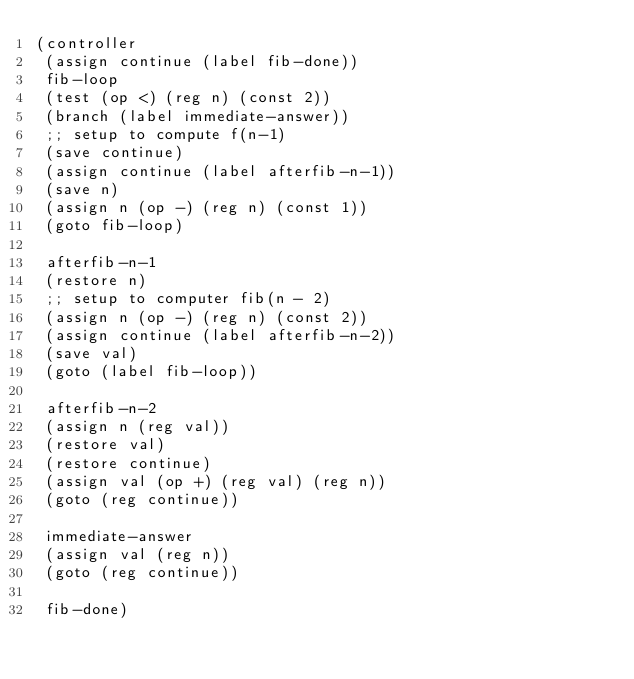Convert code to text. <code><loc_0><loc_0><loc_500><loc_500><_Scheme_>(controller
 (assign continue (label fib-done))
 fib-loop
 (test (op <) (reg n) (const 2))
 (branch (label immediate-answer))
 ;; setup to compute f(n-1)
 (save continue)
 (assign continue (label afterfib-n-1))
 (save n)
 (assign n (op -) (reg n) (const 1))
 (goto fib-loop)

 afterfib-n-1
 (restore n)
 ;; setup to computer fib(n - 2)
 (assign n (op -) (reg n) (const 2))
 (assign continue (label afterfib-n-2))
 (save val)
 (goto (label fib-loop))

 afterfib-n-2
 (assign n (reg val))
 (restore val)
 (restore continue)
 (assign val (op +) (reg val) (reg n))
 (goto (reg continue))

 immediate-answer
 (assign val (reg n))
 (goto (reg continue))

 fib-done)
</code> 